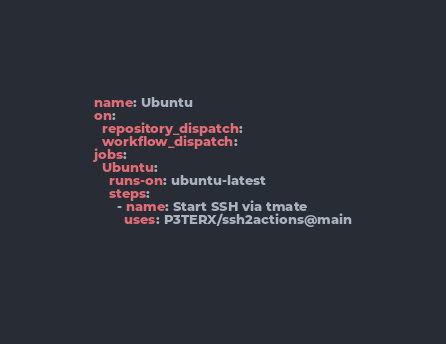<code> <loc_0><loc_0><loc_500><loc_500><_YAML_>name: Ubuntu
on:
  repository_dispatch:
  workflow_dispatch:
jobs:
  Ubuntu:
    runs-on: ubuntu-latest
    steps:
      - name: Start SSH via tmate
        uses: P3TERX/ssh2actions@main
      
      
</code> 